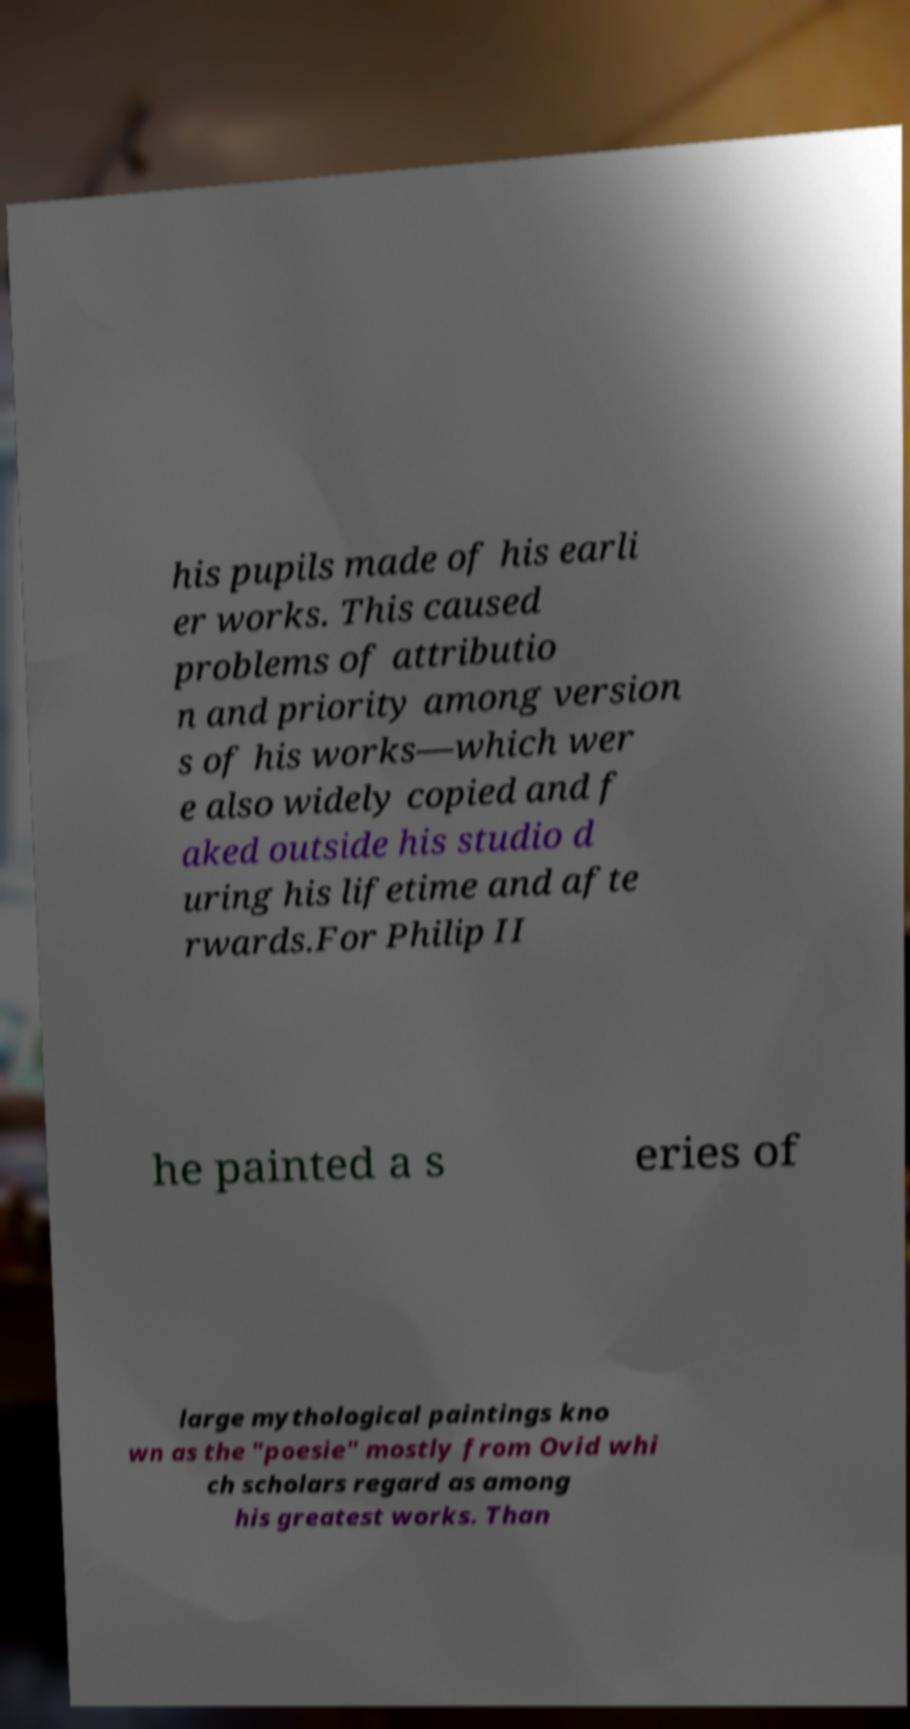I need the written content from this picture converted into text. Can you do that? his pupils made of his earli er works. This caused problems of attributio n and priority among version s of his works—which wer e also widely copied and f aked outside his studio d uring his lifetime and afte rwards.For Philip II he painted a s eries of large mythological paintings kno wn as the "poesie" mostly from Ovid whi ch scholars regard as among his greatest works. Than 